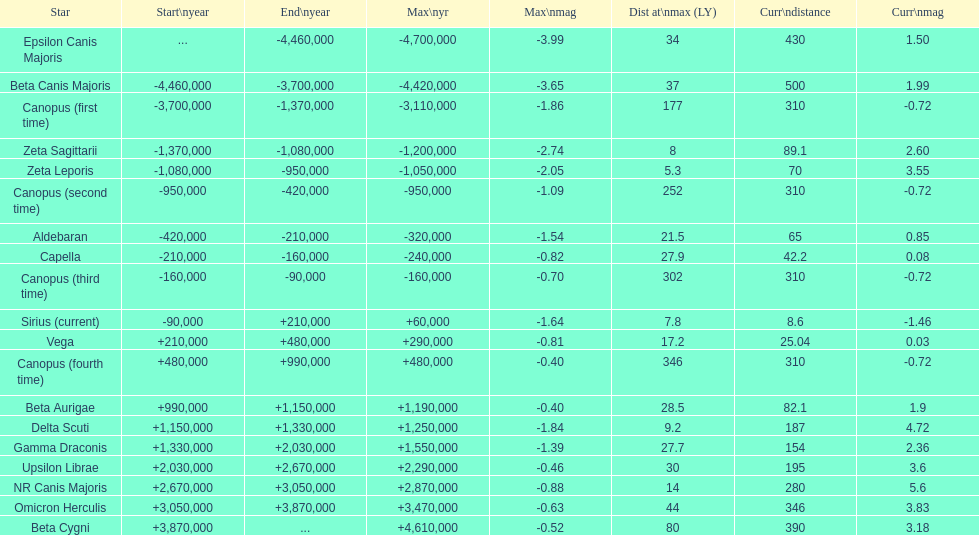How many stars have a magnitude greater than zero? 14. 